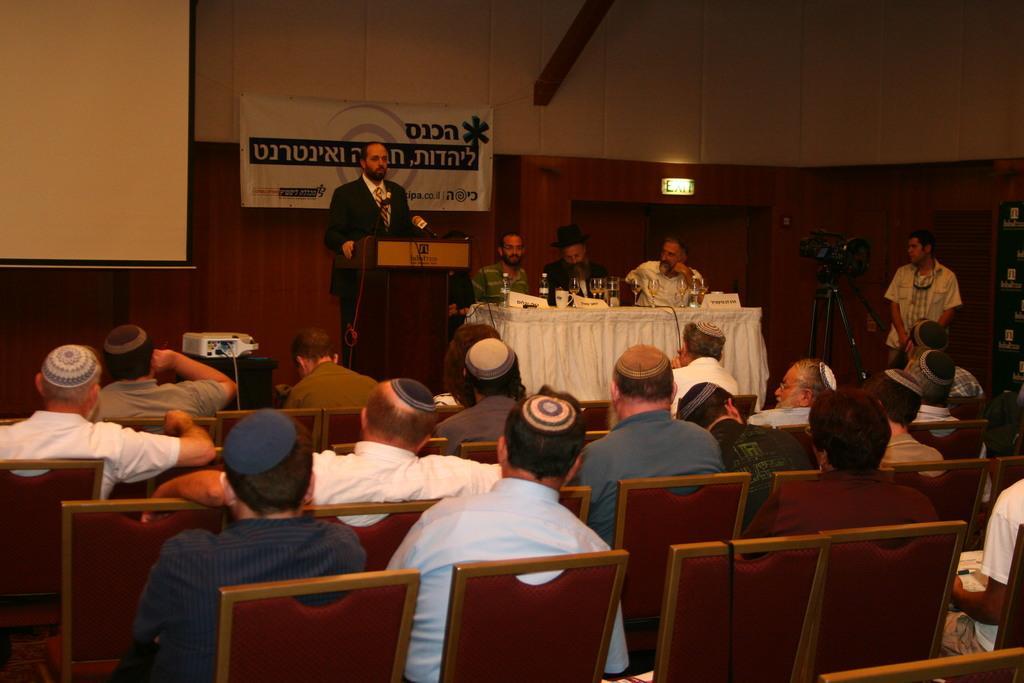Please provide a concise description of this image. On the background we can see a white board, banner and a person standing in front of a podium. This is a door, exit board. A man is standing near to the camera. We can see three persons are sitting on chairs in front a table and on the table we can see bottles, name boards. We can see persons sitting on chairs near to the platform. 